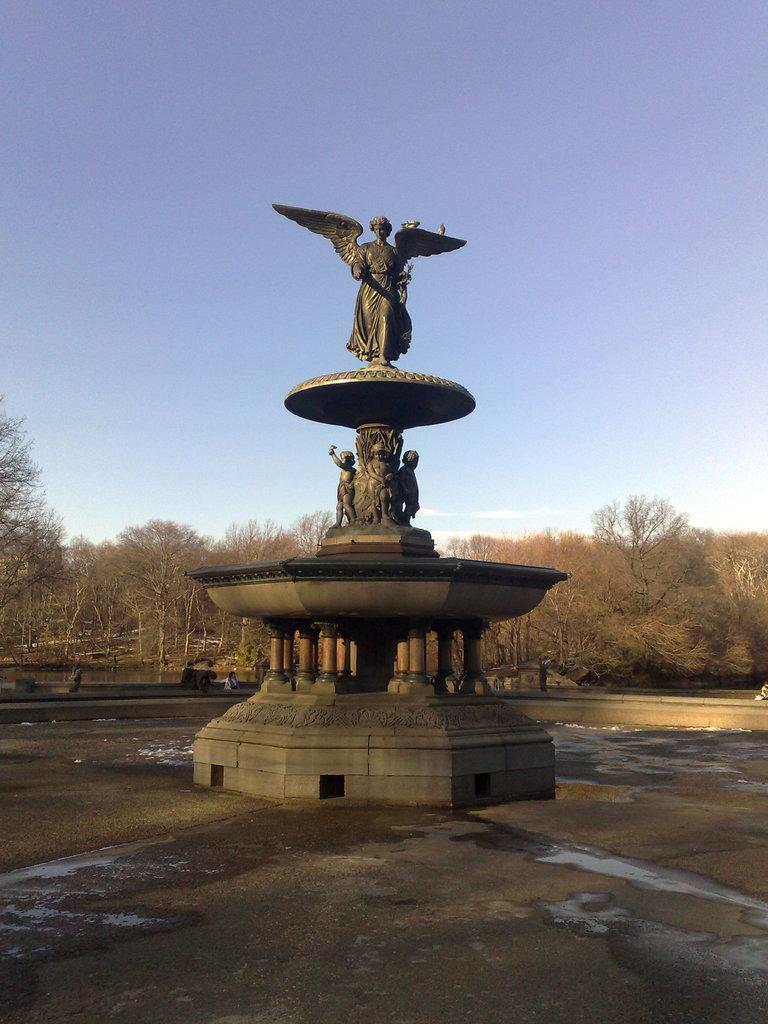What is the main feature in the image? There is a fountain in the image. What can be seen in the background of the image? There are trees and clouds visible in the sky in the background of the image. What type of pies are being sold at the railway station in the image? There is no railway station or pies present in the image; it features a fountain and trees in the background. 